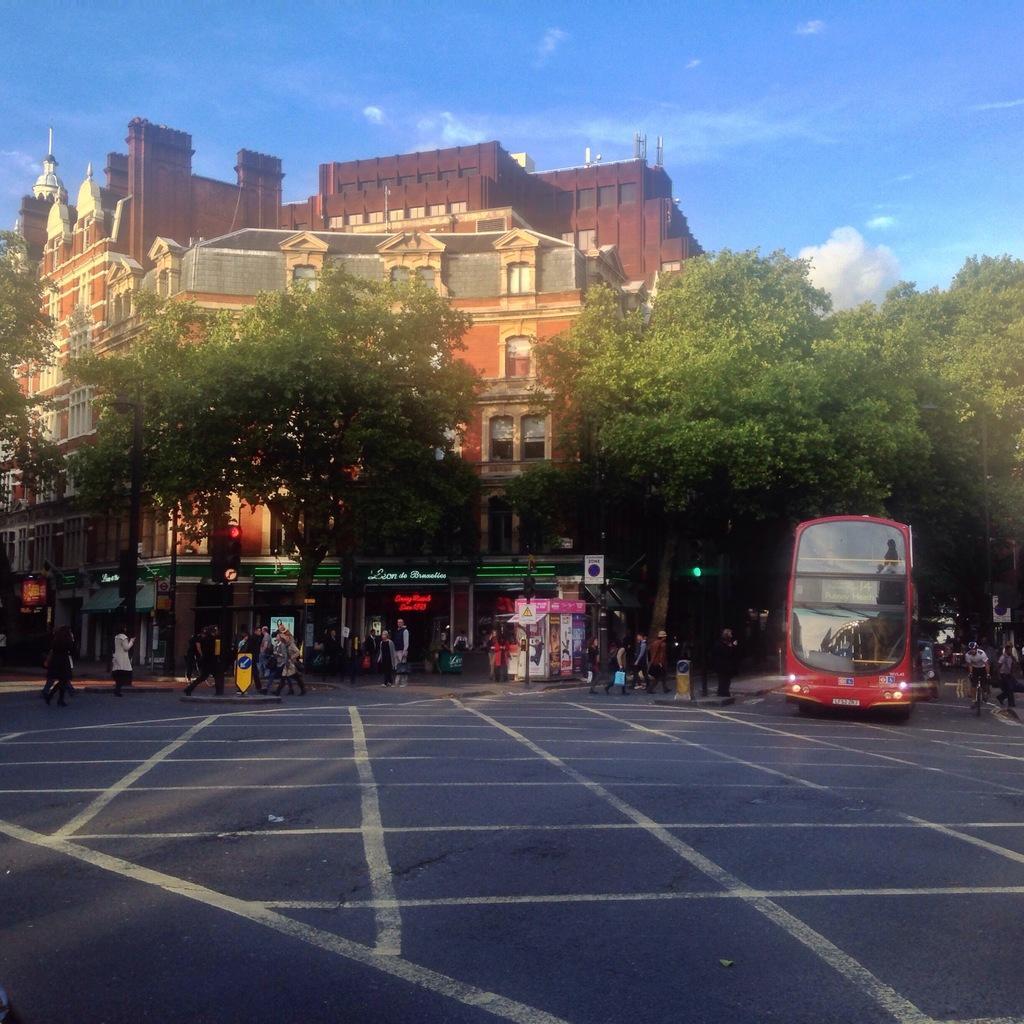How would you summarize this image in a sentence or two? In the foreground of the picture I can see the road. I can see a red color double Decker bus on the road on the right side. There is a person with a bicycle on the road on the right side. I can see a few people walking on the road. In the background, I can see the buildings and trees. There are clouds in the sky. 